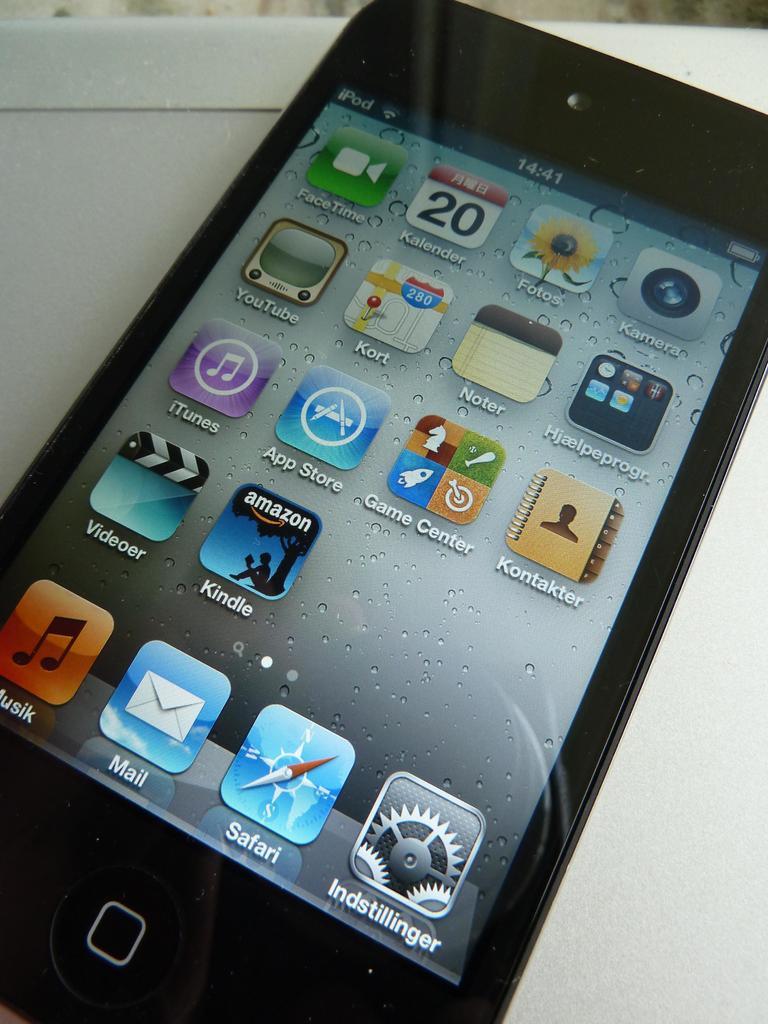What application has an envelope icon?
Keep it short and to the point. Mail. 